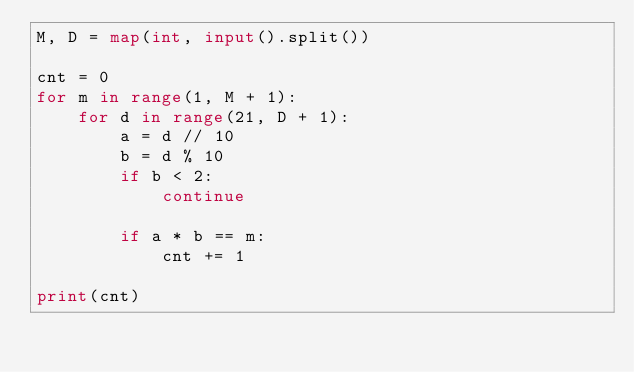<code> <loc_0><loc_0><loc_500><loc_500><_Python_>M, D = map(int, input().split())

cnt = 0
for m in range(1, M + 1):
    for d in range(21, D + 1):
        a = d // 10
        b = d % 10
        if b < 2:
            continue

        if a * b == m:
            cnt += 1

print(cnt)
</code> 